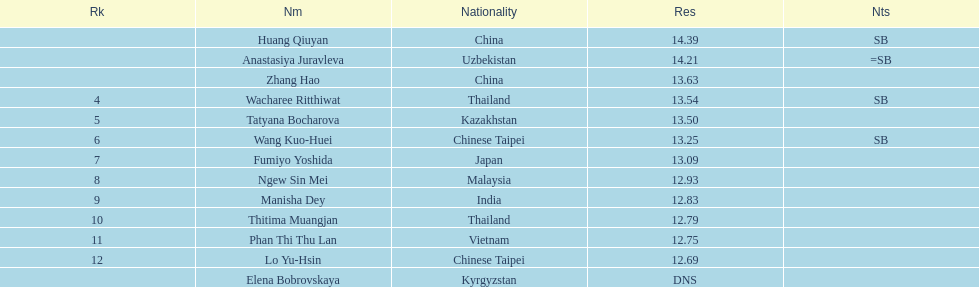How many athletes were from china? 2. 